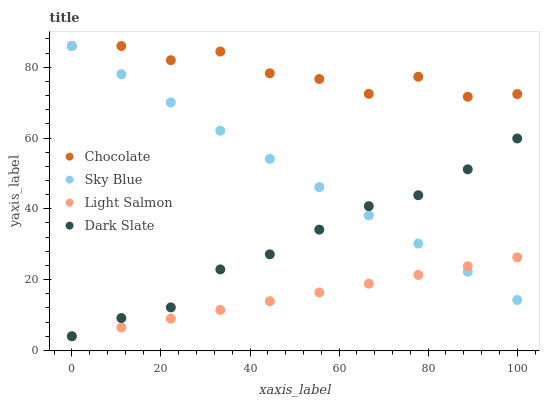Does Light Salmon have the minimum area under the curve?
Answer yes or no. Yes. Does Chocolate have the maximum area under the curve?
Answer yes or no. Yes. Does Dark Slate have the minimum area under the curve?
Answer yes or no. No. Does Dark Slate have the maximum area under the curve?
Answer yes or no. No. Is Light Salmon the smoothest?
Answer yes or no. Yes. Is Chocolate the roughest?
Answer yes or no. Yes. Is Dark Slate the smoothest?
Answer yes or no. No. Is Dark Slate the roughest?
Answer yes or no. No. Does Light Salmon have the lowest value?
Answer yes or no. Yes. Does Chocolate have the lowest value?
Answer yes or no. No. Does Chocolate have the highest value?
Answer yes or no. Yes. Does Dark Slate have the highest value?
Answer yes or no. No. Is Light Salmon less than Chocolate?
Answer yes or no. Yes. Is Chocolate greater than Dark Slate?
Answer yes or no. Yes. Does Dark Slate intersect Light Salmon?
Answer yes or no. Yes. Is Dark Slate less than Light Salmon?
Answer yes or no. No. Is Dark Slate greater than Light Salmon?
Answer yes or no. No. Does Light Salmon intersect Chocolate?
Answer yes or no. No. 